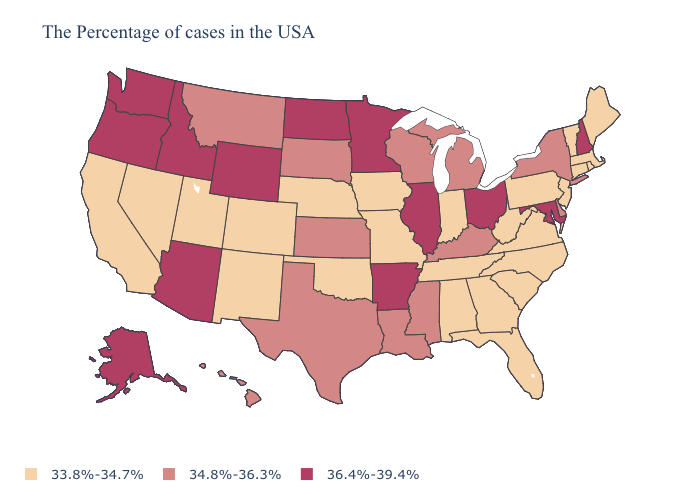What is the value of Oklahoma?
Quick response, please. 33.8%-34.7%. Name the states that have a value in the range 33.8%-34.7%?
Give a very brief answer. Maine, Massachusetts, Rhode Island, Vermont, Connecticut, New Jersey, Pennsylvania, Virginia, North Carolina, South Carolina, West Virginia, Florida, Georgia, Indiana, Alabama, Tennessee, Missouri, Iowa, Nebraska, Oklahoma, Colorado, New Mexico, Utah, Nevada, California. Name the states that have a value in the range 34.8%-36.3%?
Write a very short answer. New York, Delaware, Michigan, Kentucky, Wisconsin, Mississippi, Louisiana, Kansas, Texas, South Dakota, Montana, Hawaii. What is the value of Ohio?
Keep it brief. 36.4%-39.4%. Name the states that have a value in the range 33.8%-34.7%?
Answer briefly. Maine, Massachusetts, Rhode Island, Vermont, Connecticut, New Jersey, Pennsylvania, Virginia, North Carolina, South Carolina, West Virginia, Florida, Georgia, Indiana, Alabama, Tennessee, Missouri, Iowa, Nebraska, Oklahoma, Colorado, New Mexico, Utah, Nevada, California. What is the highest value in states that border Minnesota?
Write a very short answer. 36.4%-39.4%. Among the states that border Illinois , which have the lowest value?
Keep it brief. Indiana, Missouri, Iowa. Does the map have missing data?
Write a very short answer. No. What is the value of Alabama?
Give a very brief answer. 33.8%-34.7%. How many symbols are there in the legend?
Be succinct. 3. Is the legend a continuous bar?
Concise answer only. No. Does Florida have a lower value than Arkansas?
Be succinct. Yes. What is the value of Vermont?
Give a very brief answer. 33.8%-34.7%. Which states have the highest value in the USA?
Give a very brief answer. New Hampshire, Maryland, Ohio, Illinois, Arkansas, Minnesota, North Dakota, Wyoming, Arizona, Idaho, Washington, Oregon, Alaska. Name the states that have a value in the range 36.4%-39.4%?
Quick response, please. New Hampshire, Maryland, Ohio, Illinois, Arkansas, Minnesota, North Dakota, Wyoming, Arizona, Idaho, Washington, Oregon, Alaska. 